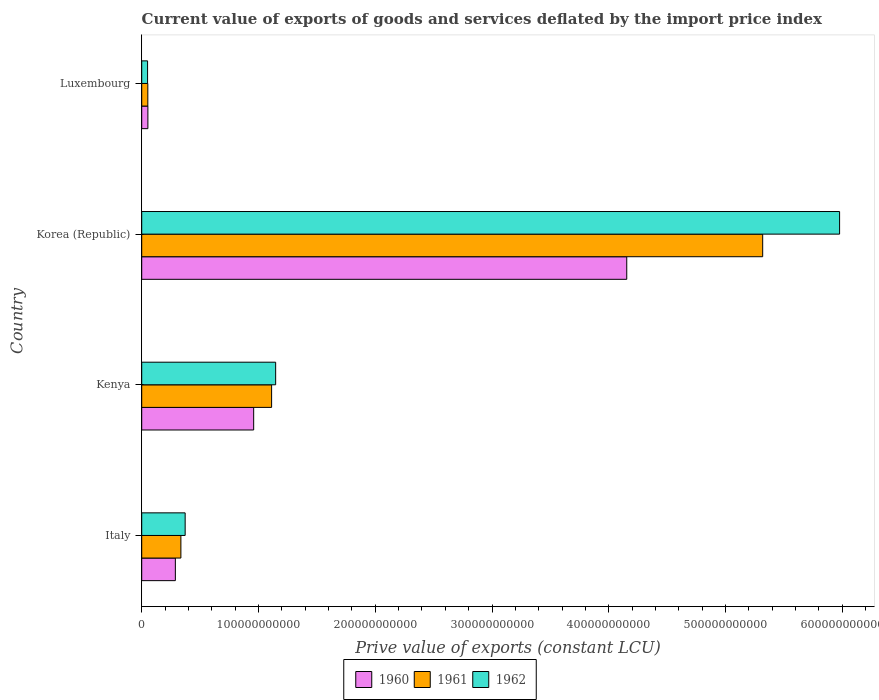Are the number of bars on each tick of the Y-axis equal?
Provide a short and direct response. Yes. What is the label of the 1st group of bars from the top?
Ensure brevity in your answer.  Luxembourg. In how many cases, is the number of bars for a given country not equal to the number of legend labels?
Your response must be concise. 0. What is the prive value of exports in 1960 in Korea (Republic)?
Provide a succinct answer. 4.15e+11. Across all countries, what is the maximum prive value of exports in 1960?
Give a very brief answer. 4.15e+11. Across all countries, what is the minimum prive value of exports in 1962?
Make the answer very short. 5.02e+09. In which country was the prive value of exports in 1961 minimum?
Keep it short and to the point. Luxembourg. What is the total prive value of exports in 1960 in the graph?
Your response must be concise. 5.45e+11. What is the difference between the prive value of exports in 1961 in Kenya and that in Korea (Republic)?
Your response must be concise. -4.21e+11. What is the difference between the prive value of exports in 1961 in Kenya and the prive value of exports in 1960 in Korea (Republic)?
Offer a very short reply. -3.04e+11. What is the average prive value of exports in 1962 per country?
Your answer should be compact. 1.89e+11. What is the difference between the prive value of exports in 1961 and prive value of exports in 1960 in Korea (Republic)?
Ensure brevity in your answer.  1.16e+11. In how many countries, is the prive value of exports in 1960 greater than 100000000000 LCU?
Offer a terse response. 1. What is the ratio of the prive value of exports in 1962 in Italy to that in Luxembourg?
Your answer should be compact. 7.42. What is the difference between the highest and the second highest prive value of exports in 1961?
Your answer should be very brief. 4.21e+11. What is the difference between the highest and the lowest prive value of exports in 1961?
Ensure brevity in your answer.  5.27e+11. In how many countries, is the prive value of exports in 1961 greater than the average prive value of exports in 1961 taken over all countries?
Keep it short and to the point. 1. Is it the case that in every country, the sum of the prive value of exports in 1962 and prive value of exports in 1961 is greater than the prive value of exports in 1960?
Offer a very short reply. Yes. How many bars are there?
Offer a terse response. 12. What is the difference between two consecutive major ticks on the X-axis?
Provide a succinct answer. 1.00e+11. Are the values on the major ticks of X-axis written in scientific E-notation?
Provide a succinct answer. No. Does the graph contain grids?
Ensure brevity in your answer.  No. Where does the legend appear in the graph?
Your answer should be compact. Bottom center. How many legend labels are there?
Your answer should be very brief. 3. How are the legend labels stacked?
Keep it short and to the point. Horizontal. What is the title of the graph?
Your answer should be compact. Current value of exports of goods and services deflated by the import price index. What is the label or title of the X-axis?
Make the answer very short. Prive value of exports (constant LCU). What is the Prive value of exports (constant LCU) of 1960 in Italy?
Give a very brief answer. 2.88e+1. What is the Prive value of exports (constant LCU) in 1961 in Italy?
Offer a very short reply. 3.35e+1. What is the Prive value of exports (constant LCU) of 1962 in Italy?
Provide a short and direct response. 3.72e+1. What is the Prive value of exports (constant LCU) of 1960 in Kenya?
Give a very brief answer. 9.59e+1. What is the Prive value of exports (constant LCU) of 1961 in Kenya?
Your answer should be compact. 1.11e+11. What is the Prive value of exports (constant LCU) in 1962 in Kenya?
Provide a succinct answer. 1.15e+11. What is the Prive value of exports (constant LCU) of 1960 in Korea (Republic)?
Provide a succinct answer. 4.15e+11. What is the Prive value of exports (constant LCU) in 1961 in Korea (Republic)?
Ensure brevity in your answer.  5.32e+11. What is the Prive value of exports (constant LCU) of 1962 in Korea (Republic)?
Give a very brief answer. 5.98e+11. What is the Prive value of exports (constant LCU) of 1960 in Luxembourg?
Your response must be concise. 5.28e+09. What is the Prive value of exports (constant LCU) in 1961 in Luxembourg?
Offer a terse response. 5.22e+09. What is the Prive value of exports (constant LCU) of 1962 in Luxembourg?
Keep it short and to the point. 5.02e+09. Across all countries, what is the maximum Prive value of exports (constant LCU) of 1960?
Provide a short and direct response. 4.15e+11. Across all countries, what is the maximum Prive value of exports (constant LCU) of 1961?
Provide a succinct answer. 5.32e+11. Across all countries, what is the maximum Prive value of exports (constant LCU) of 1962?
Provide a succinct answer. 5.98e+11. Across all countries, what is the minimum Prive value of exports (constant LCU) in 1960?
Offer a very short reply. 5.28e+09. Across all countries, what is the minimum Prive value of exports (constant LCU) of 1961?
Make the answer very short. 5.22e+09. Across all countries, what is the minimum Prive value of exports (constant LCU) of 1962?
Offer a terse response. 5.02e+09. What is the total Prive value of exports (constant LCU) in 1960 in the graph?
Offer a terse response. 5.45e+11. What is the total Prive value of exports (constant LCU) of 1961 in the graph?
Ensure brevity in your answer.  6.82e+11. What is the total Prive value of exports (constant LCU) in 1962 in the graph?
Give a very brief answer. 7.55e+11. What is the difference between the Prive value of exports (constant LCU) of 1960 in Italy and that in Kenya?
Ensure brevity in your answer.  -6.71e+1. What is the difference between the Prive value of exports (constant LCU) of 1961 in Italy and that in Kenya?
Offer a very short reply. -7.77e+1. What is the difference between the Prive value of exports (constant LCU) of 1962 in Italy and that in Kenya?
Ensure brevity in your answer.  -7.75e+1. What is the difference between the Prive value of exports (constant LCU) of 1960 in Italy and that in Korea (Republic)?
Ensure brevity in your answer.  -3.87e+11. What is the difference between the Prive value of exports (constant LCU) of 1961 in Italy and that in Korea (Republic)?
Make the answer very short. -4.98e+11. What is the difference between the Prive value of exports (constant LCU) of 1962 in Italy and that in Korea (Republic)?
Give a very brief answer. -5.60e+11. What is the difference between the Prive value of exports (constant LCU) in 1960 in Italy and that in Luxembourg?
Your response must be concise. 2.35e+1. What is the difference between the Prive value of exports (constant LCU) of 1961 in Italy and that in Luxembourg?
Your answer should be very brief. 2.83e+1. What is the difference between the Prive value of exports (constant LCU) in 1962 in Italy and that in Luxembourg?
Offer a very short reply. 3.22e+1. What is the difference between the Prive value of exports (constant LCU) in 1960 in Kenya and that in Korea (Republic)?
Offer a very short reply. -3.19e+11. What is the difference between the Prive value of exports (constant LCU) of 1961 in Kenya and that in Korea (Republic)?
Your answer should be compact. -4.21e+11. What is the difference between the Prive value of exports (constant LCU) of 1962 in Kenya and that in Korea (Republic)?
Keep it short and to the point. -4.83e+11. What is the difference between the Prive value of exports (constant LCU) in 1960 in Kenya and that in Luxembourg?
Your response must be concise. 9.06e+1. What is the difference between the Prive value of exports (constant LCU) of 1961 in Kenya and that in Luxembourg?
Offer a very short reply. 1.06e+11. What is the difference between the Prive value of exports (constant LCU) of 1962 in Kenya and that in Luxembourg?
Ensure brevity in your answer.  1.10e+11. What is the difference between the Prive value of exports (constant LCU) of 1960 in Korea (Republic) and that in Luxembourg?
Ensure brevity in your answer.  4.10e+11. What is the difference between the Prive value of exports (constant LCU) of 1961 in Korea (Republic) and that in Luxembourg?
Your response must be concise. 5.27e+11. What is the difference between the Prive value of exports (constant LCU) in 1962 in Korea (Republic) and that in Luxembourg?
Provide a succinct answer. 5.93e+11. What is the difference between the Prive value of exports (constant LCU) in 1960 in Italy and the Prive value of exports (constant LCU) in 1961 in Kenya?
Give a very brief answer. -8.24e+1. What is the difference between the Prive value of exports (constant LCU) of 1960 in Italy and the Prive value of exports (constant LCU) of 1962 in Kenya?
Offer a very short reply. -8.59e+1. What is the difference between the Prive value of exports (constant LCU) of 1961 in Italy and the Prive value of exports (constant LCU) of 1962 in Kenya?
Provide a succinct answer. -8.12e+1. What is the difference between the Prive value of exports (constant LCU) in 1960 in Italy and the Prive value of exports (constant LCU) in 1961 in Korea (Republic)?
Your response must be concise. -5.03e+11. What is the difference between the Prive value of exports (constant LCU) of 1960 in Italy and the Prive value of exports (constant LCU) of 1962 in Korea (Republic)?
Your answer should be compact. -5.69e+11. What is the difference between the Prive value of exports (constant LCU) of 1961 in Italy and the Prive value of exports (constant LCU) of 1962 in Korea (Republic)?
Offer a terse response. -5.64e+11. What is the difference between the Prive value of exports (constant LCU) of 1960 in Italy and the Prive value of exports (constant LCU) of 1961 in Luxembourg?
Offer a very short reply. 2.36e+1. What is the difference between the Prive value of exports (constant LCU) in 1960 in Italy and the Prive value of exports (constant LCU) in 1962 in Luxembourg?
Offer a very short reply. 2.38e+1. What is the difference between the Prive value of exports (constant LCU) in 1961 in Italy and the Prive value of exports (constant LCU) in 1962 in Luxembourg?
Make the answer very short. 2.85e+1. What is the difference between the Prive value of exports (constant LCU) in 1960 in Kenya and the Prive value of exports (constant LCU) in 1961 in Korea (Republic)?
Your response must be concise. -4.36e+11. What is the difference between the Prive value of exports (constant LCU) of 1960 in Kenya and the Prive value of exports (constant LCU) of 1962 in Korea (Republic)?
Offer a terse response. -5.02e+11. What is the difference between the Prive value of exports (constant LCU) of 1961 in Kenya and the Prive value of exports (constant LCU) of 1962 in Korea (Republic)?
Ensure brevity in your answer.  -4.86e+11. What is the difference between the Prive value of exports (constant LCU) of 1960 in Kenya and the Prive value of exports (constant LCU) of 1961 in Luxembourg?
Your answer should be very brief. 9.07e+1. What is the difference between the Prive value of exports (constant LCU) in 1960 in Kenya and the Prive value of exports (constant LCU) in 1962 in Luxembourg?
Offer a very short reply. 9.09e+1. What is the difference between the Prive value of exports (constant LCU) of 1961 in Kenya and the Prive value of exports (constant LCU) of 1962 in Luxembourg?
Give a very brief answer. 1.06e+11. What is the difference between the Prive value of exports (constant LCU) in 1960 in Korea (Republic) and the Prive value of exports (constant LCU) in 1961 in Luxembourg?
Your answer should be compact. 4.10e+11. What is the difference between the Prive value of exports (constant LCU) in 1960 in Korea (Republic) and the Prive value of exports (constant LCU) in 1962 in Luxembourg?
Ensure brevity in your answer.  4.10e+11. What is the difference between the Prive value of exports (constant LCU) in 1961 in Korea (Republic) and the Prive value of exports (constant LCU) in 1962 in Luxembourg?
Ensure brevity in your answer.  5.27e+11. What is the average Prive value of exports (constant LCU) in 1960 per country?
Your answer should be compact. 1.36e+11. What is the average Prive value of exports (constant LCU) of 1961 per country?
Give a very brief answer. 1.70e+11. What is the average Prive value of exports (constant LCU) in 1962 per country?
Offer a very short reply. 1.89e+11. What is the difference between the Prive value of exports (constant LCU) of 1960 and Prive value of exports (constant LCU) of 1961 in Italy?
Offer a terse response. -4.73e+09. What is the difference between the Prive value of exports (constant LCU) in 1960 and Prive value of exports (constant LCU) in 1962 in Italy?
Your answer should be very brief. -8.38e+09. What is the difference between the Prive value of exports (constant LCU) in 1961 and Prive value of exports (constant LCU) in 1962 in Italy?
Provide a succinct answer. -3.65e+09. What is the difference between the Prive value of exports (constant LCU) of 1960 and Prive value of exports (constant LCU) of 1961 in Kenya?
Your answer should be compact. -1.54e+1. What is the difference between the Prive value of exports (constant LCU) of 1960 and Prive value of exports (constant LCU) of 1962 in Kenya?
Give a very brief answer. -1.88e+1. What is the difference between the Prive value of exports (constant LCU) in 1961 and Prive value of exports (constant LCU) in 1962 in Kenya?
Give a very brief answer. -3.47e+09. What is the difference between the Prive value of exports (constant LCU) in 1960 and Prive value of exports (constant LCU) in 1961 in Korea (Republic)?
Offer a terse response. -1.16e+11. What is the difference between the Prive value of exports (constant LCU) of 1960 and Prive value of exports (constant LCU) of 1962 in Korea (Republic)?
Make the answer very short. -1.82e+11. What is the difference between the Prive value of exports (constant LCU) of 1961 and Prive value of exports (constant LCU) of 1962 in Korea (Republic)?
Provide a succinct answer. -6.59e+1. What is the difference between the Prive value of exports (constant LCU) of 1960 and Prive value of exports (constant LCU) of 1961 in Luxembourg?
Your answer should be compact. 5.55e+07. What is the difference between the Prive value of exports (constant LCU) in 1960 and Prive value of exports (constant LCU) in 1962 in Luxembourg?
Provide a short and direct response. 2.64e+08. What is the difference between the Prive value of exports (constant LCU) in 1961 and Prive value of exports (constant LCU) in 1962 in Luxembourg?
Your response must be concise. 2.08e+08. What is the ratio of the Prive value of exports (constant LCU) of 1960 in Italy to that in Kenya?
Provide a short and direct response. 0.3. What is the ratio of the Prive value of exports (constant LCU) in 1961 in Italy to that in Kenya?
Give a very brief answer. 0.3. What is the ratio of the Prive value of exports (constant LCU) of 1962 in Italy to that in Kenya?
Provide a succinct answer. 0.32. What is the ratio of the Prive value of exports (constant LCU) of 1960 in Italy to that in Korea (Republic)?
Your answer should be compact. 0.07. What is the ratio of the Prive value of exports (constant LCU) of 1961 in Italy to that in Korea (Republic)?
Your answer should be compact. 0.06. What is the ratio of the Prive value of exports (constant LCU) in 1962 in Italy to that in Korea (Republic)?
Ensure brevity in your answer.  0.06. What is the ratio of the Prive value of exports (constant LCU) of 1960 in Italy to that in Luxembourg?
Your answer should be compact. 5.46. What is the ratio of the Prive value of exports (constant LCU) in 1961 in Italy to that in Luxembourg?
Provide a short and direct response. 6.42. What is the ratio of the Prive value of exports (constant LCU) in 1962 in Italy to that in Luxembourg?
Provide a succinct answer. 7.42. What is the ratio of the Prive value of exports (constant LCU) in 1960 in Kenya to that in Korea (Republic)?
Provide a succinct answer. 0.23. What is the ratio of the Prive value of exports (constant LCU) of 1961 in Kenya to that in Korea (Republic)?
Make the answer very short. 0.21. What is the ratio of the Prive value of exports (constant LCU) in 1962 in Kenya to that in Korea (Republic)?
Your response must be concise. 0.19. What is the ratio of the Prive value of exports (constant LCU) of 1960 in Kenya to that in Luxembourg?
Provide a succinct answer. 18.16. What is the ratio of the Prive value of exports (constant LCU) of 1961 in Kenya to that in Luxembourg?
Offer a terse response. 21.29. What is the ratio of the Prive value of exports (constant LCU) of 1962 in Kenya to that in Luxembourg?
Give a very brief answer. 22.87. What is the ratio of the Prive value of exports (constant LCU) of 1960 in Korea (Republic) to that in Luxembourg?
Provide a short and direct response. 78.67. What is the ratio of the Prive value of exports (constant LCU) of 1961 in Korea (Republic) to that in Luxembourg?
Your answer should be compact. 101.79. What is the ratio of the Prive value of exports (constant LCU) in 1962 in Korea (Republic) to that in Luxembourg?
Make the answer very short. 119.15. What is the difference between the highest and the second highest Prive value of exports (constant LCU) in 1960?
Make the answer very short. 3.19e+11. What is the difference between the highest and the second highest Prive value of exports (constant LCU) of 1961?
Offer a terse response. 4.21e+11. What is the difference between the highest and the second highest Prive value of exports (constant LCU) of 1962?
Keep it short and to the point. 4.83e+11. What is the difference between the highest and the lowest Prive value of exports (constant LCU) in 1960?
Ensure brevity in your answer.  4.10e+11. What is the difference between the highest and the lowest Prive value of exports (constant LCU) of 1961?
Offer a very short reply. 5.27e+11. What is the difference between the highest and the lowest Prive value of exports (constant LCU) in 1962?
Offer a very short reply. 5.93e+11. 